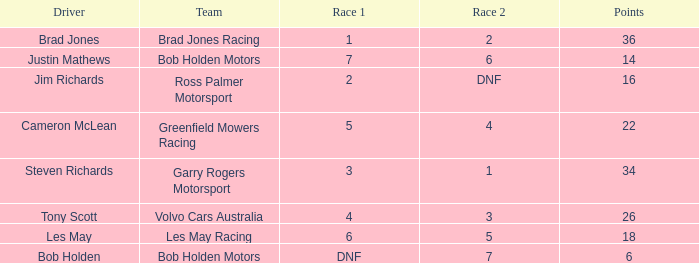Which driver for Greenfield Mowers Racing has fewer than 36 points? Cameron McLean. 